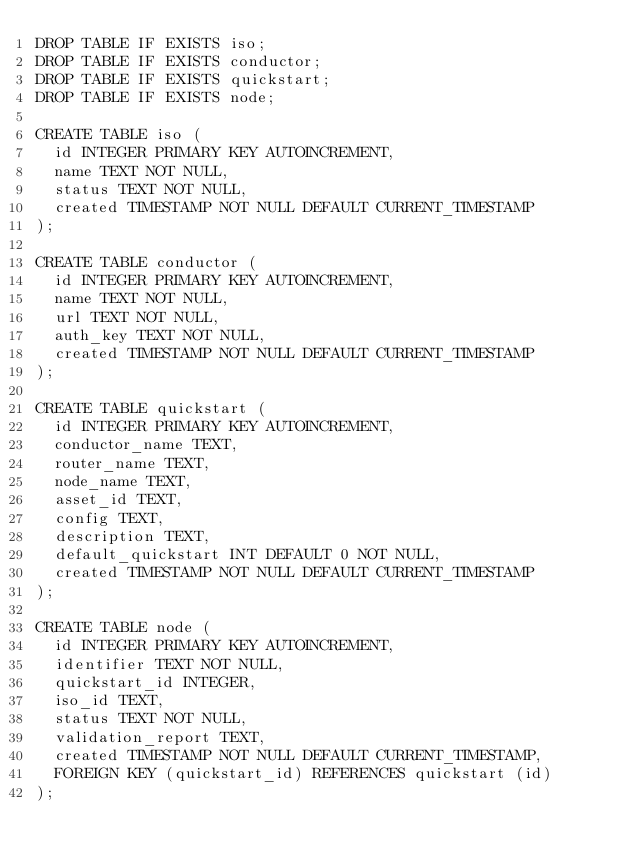Convert code to text. <code><loc_0><loc_0><loc_500><loc_500><_SQL_>DROP TABLE IF EXISTS iso;
DROP TABLE IF EXISTS conductor;
DROP TABLE IF EXISTS quickstart;
DROP TABLE IF EXISTS node;

CREATE TABLE iso (
  id INTEGER PRIMARY KEY AUTOINCREMENT,
  name TEXT NOT NULL,
  status TEXT NOT NULL,
  created TIMESTAMP NOT NULL DEFAULT CURRENT_TIMESTAMP
);

CREATE TABLE conductor (
  id INTEGER PRIMARY KEY AUTOINCREMENT,
  name TEXT NOT NULL,
  url TEXT NOT NULL,
  auth_key TEXT NOT NULL,
  created TIMESTAMP NOT NULL DEFAULT CURRENT_TIMESTAMP
);

CREATE TABLE quickstart (
  id INTEGER PRIMARY KEY AUTOINCREMENT,
  conductor_name TEXT,
  router_name TEXT,
  node_name TEXT,
  asset_id TEXT,
  config TEXT,
  description TEXT,
  default_quickstart INT DEFAULT 0 NOT NULL,
  created TIMESTAMP NOT NULL DEFAULT CURRENT_TIMESTAMP
);

CREATE TABLE node (
  id INTEGER PRIMARY KEY AUTOINCREMENT,
  identifier TEXT NOT NULL,
  quickstart_id INTEGER,
  iso_id TEXT,
  status TEXT NOT NULL,
  validation_report TEXT,
  created TIMESTAMP NOT NULL DEFAULT CURRENT_TIMESTAMP,
  FOREIGN KEY (quickstart_id) REFERENCES quickstart (id)
);
</code> 